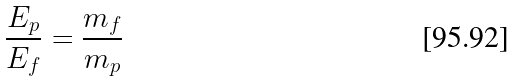Convert formula to latex. <formula><loc_0><loc_0><loc_500><loc_500>\frac { E _ { p } } { E _ { f } } = \frac { m _ { f } } { m _ { p } }</formula> 